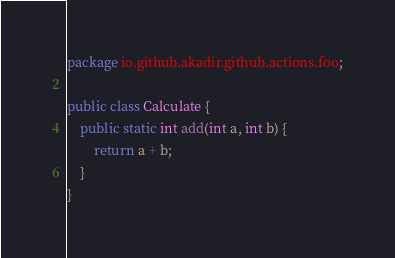<code> <loc_0><loc_0><loc_500><loc_500><_Java_>package io.github.akadir.github.actions.foo;

public class Calculate {
    public static int add(int a, int b) {
        return a + b;
    }
}
</code> 